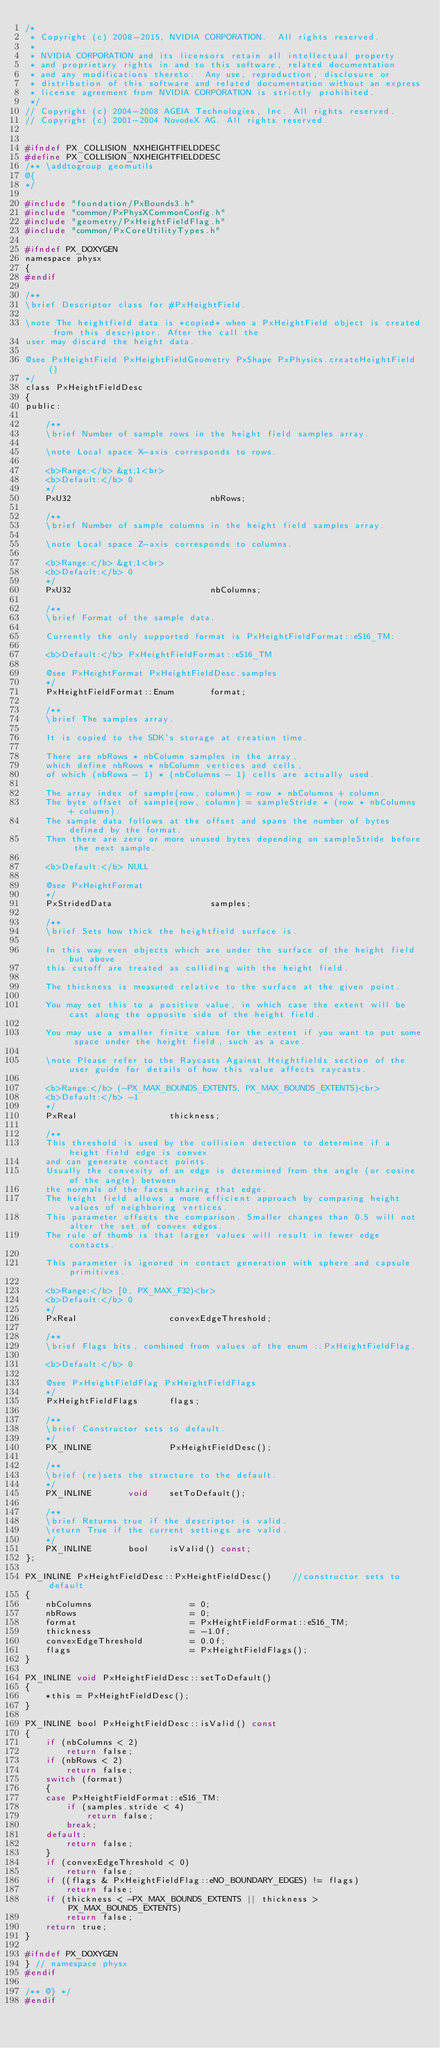<code> <loc_0><loc_0><loc_500><loc_500><_C_>/*
 * Copyright (c) 2008-2015, NVIDIA CORPORATION.  All rights reserved.
 *
 * NVIDIA CORPORATION and its licensors retain all intellectual property
 * and proprietary rights in and to this software, related documentation
 * and any modifications thereto.  Any use, reproduction, disclosure or
 * distribution of this software and related documentation without an express
 * license agreement from NVIDIA CORPORATION is strictly prohibited.
 */
// Copyright (c) 2004-2008 AGEIA Technologies, Inc. All rights reserved.
// Copyright (c) 2001-2004 NovodeX AG. All rights reserved.


#ifndef PX_COLLISION_NXHEIGHTFIELDDESC
#define PX_COLLISION_NXHEIGHTFIELDDESC
/** \addtogroup geomutils
@{
*/

#include "foundation/PxBounds3.h"
#include "common/PxPhysXCommonConfig.h"
#include "geometry/PxHeightFieldFlag.h"
#include "common/PxCoreUtilityTypes.h"

#ifndef PX_DOXYGEN
namespace physx
{
#endif

/**
\brief Descriptor class for #PxHeightField.

\note The heightfield data is *copied* when a PxHeightField object is created from this descriptor. After the call the
user may discard the height data.

@see PxHeightField PxHeightFieldGeometry PxShape PxPhysics.createHeightField()
*/
class PxHeightFieldDesc
{
public:

	/**
	\brief Number of sample rows in the height field samples array.

	\note Local space X-axis corresponds to rows.

	<b>Range:</b> &gt;1<br>
	<b>Default:</b> 0
	*/
	PxU32							nbRows;

	/**
	\brief Number of sample columns in the height field samples array.

	\note Local space Z-axis corresponds to columns.

	<b>Range:</b> &gt;1<br>
	<b>Default:</b> 0
	*/
	PxU32							nbColumns;

	/**
	\brief Format of the sample data.

	Currently the only supported format is PxHeightFieldFormat::eS16_TM:

	<b>Default:</b> PxHeightFieldFormat::eS16_TM

	@see PxHeightFormat PxHeightFieldDesc.samples
	*/
	PxHeightFieldFormat::Enum		format;

	/**
	\brief The samples array.

	It is copied to the SDK's storage at creation time.

	There are nbRows * nbColumn samples in the array,
	which define nbRows * nbColumn vertices and cells,
	of which (nbRows - 1) * (nbColumns - 1) cells are actually used.

	The array index of sample(row, column) = row * nbColumns + column.
	The byte offset of sample(row, column) = sampleStride * (row * nbColumns + column).
	The sample data follows at the offset and spans the number of bytes defined by the format.
	Then there are zero or more unused bytes depending on sampleStride before the next sample.

	<b>Default:</b> NULL

	@see PxHeightFormat
	*/
	PxStridedData					samples;

	/**
	\brief Sets how thick the heightfield surface is.

	In this way even objects which are under the surface of the height field but above
	this cutoff are treated as colliding with the height field.

	The thickness is measured relative to the surface at the given point.

	You may set this to a positive value, in which case the extent will be cast along the opposite side of the height field.

	You may use a smaller finite value for the extent if you want to put some space under the height field, such as a cave.

	\note Please refer to the Raycasts Against Heightfields section of the user guide for details of how this value affects raycasts.

	<b>Range:</b> (-PX_MAX_BOUNDS_EXTENTS, PX_MAX_BOUNDS_EXTENTS)<br>
	<b>Default:</b> -1
	*/
	PxReal					thickness;

	/**
	This threshold is used by the collision detection to determine if a height field edge is convex
	and can generate contact points.
	Usually the convexity of an edge is determined from the angle (or cosine of the angle) between
	the normals of the faces sharing that edge.
	The height field allows a more efficient approach by comparing height values of neighboring vertices.
	This parameter offsets the comparison. Smaller changes than 0.5 will not alter the set of convex edges.
	The rule of thumb is that larger values will result in fewer edge contacts.

	This parameter is ignored in contact generation with sphere and capsule primitives.

	<b>Range:</b> [0, PX_MAX_F32)<br>
	<b>Default:</b> 0
	*/
	PxReal					convexEdgeThreshold;

	/**
	\brief Flags bits, combined from values of the enum ::PxHeightFieldFlag.

	<b>Default:</b> 0

	@see PxHeightFieldFlag PxHeightFieldFlags
	*/
	PxHeightFieldFlags		flags;

	/**
	\brief Constructor sets to default.
	*/
	PX_INLINE				PxHeightFieldDesc();

	/**
	\brief (re)sets the structure to the default.
	*/
	PX_INLINE		void	setToDefault();

	/**
	\brief Returns true if the descriptor is valid.
	\return True if the current settings are valid.
	*/
	PX_INLINE		bool	isValid() const;
};

PX_INLINE PxHeightFieldDesc::PxHeightFieldDesc()	//constructor sets to default
{
	nbColumns					= 0;
	nbRows						= 0;
	format						= PxHeightFieldFormat::eS16_TM;
	thickness					= -1.0f;
	convexEdgeThreshold			= 0.0f;
	flags						= PxHeightFieldFlags();
}

PX_INLINE void PxHeightFieldDesc::setToDefault()
{
	*this = PxHeightFieldDesc();
}

PX_INLINE bool PxHeightFieldDesc::isValid() const
{
	if (nbColumns < 2)
		return false;
	if (nbRows < 2)
		return false;
	switch (format)
	{
	case PxHeightFieldFormat::eS16_TM:
		if (samples.stride < 4)
			return false;
		break;
	default:
		return false;
	}
	if (convexEdgeThreshold < 0)
		return false;
	if ((flags & PxHeightFieldFlag::eNO_BOUNDARY_EDGES) != flags)
		return false;
	if (thickness < -PX_MAX_BOUNDS_EXTENTS || thickness > PX_MAX_BOUNDS_EXTENTS)
		return false;
	return true;
}

#ifndef PX_DOXYGEN
} // namespace physx
#endif

/** @} */
#endif
</code> 